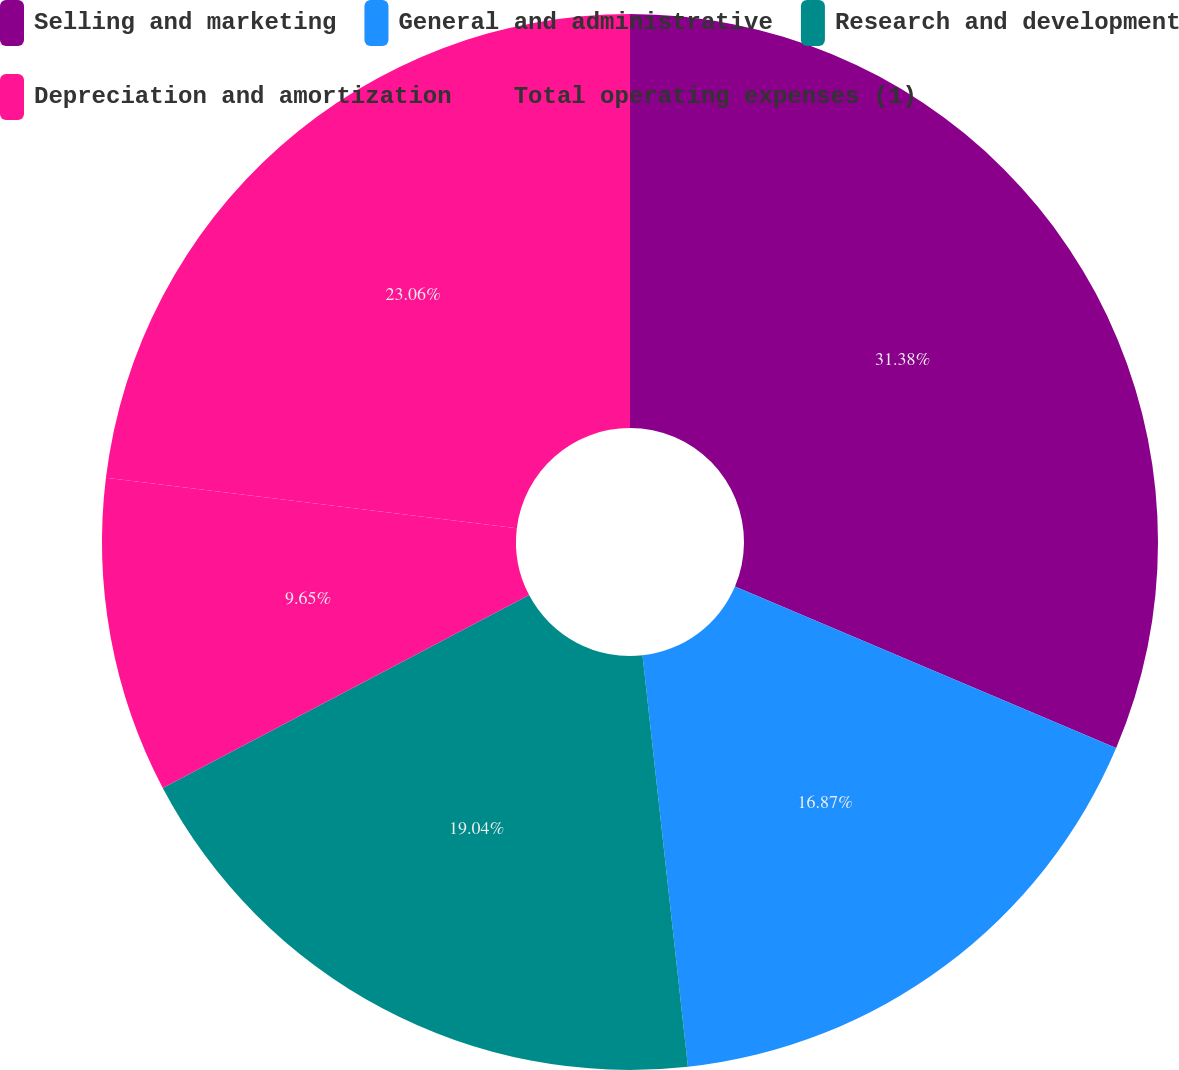Convert chart. <chart><loc_0><loc_0><loc_500><loc_500><pie_chart><fcel>Selling and marketing<fcel>General and administrative<fcel>Research and development<fcel>Depreciation and amortization<fcel>Total operating expenses (1)<nl><fcel>31.38%<fcel>16.87%<fcel>19.04%<fcel>9.65%<fcel>23.06%<nl></chart> 